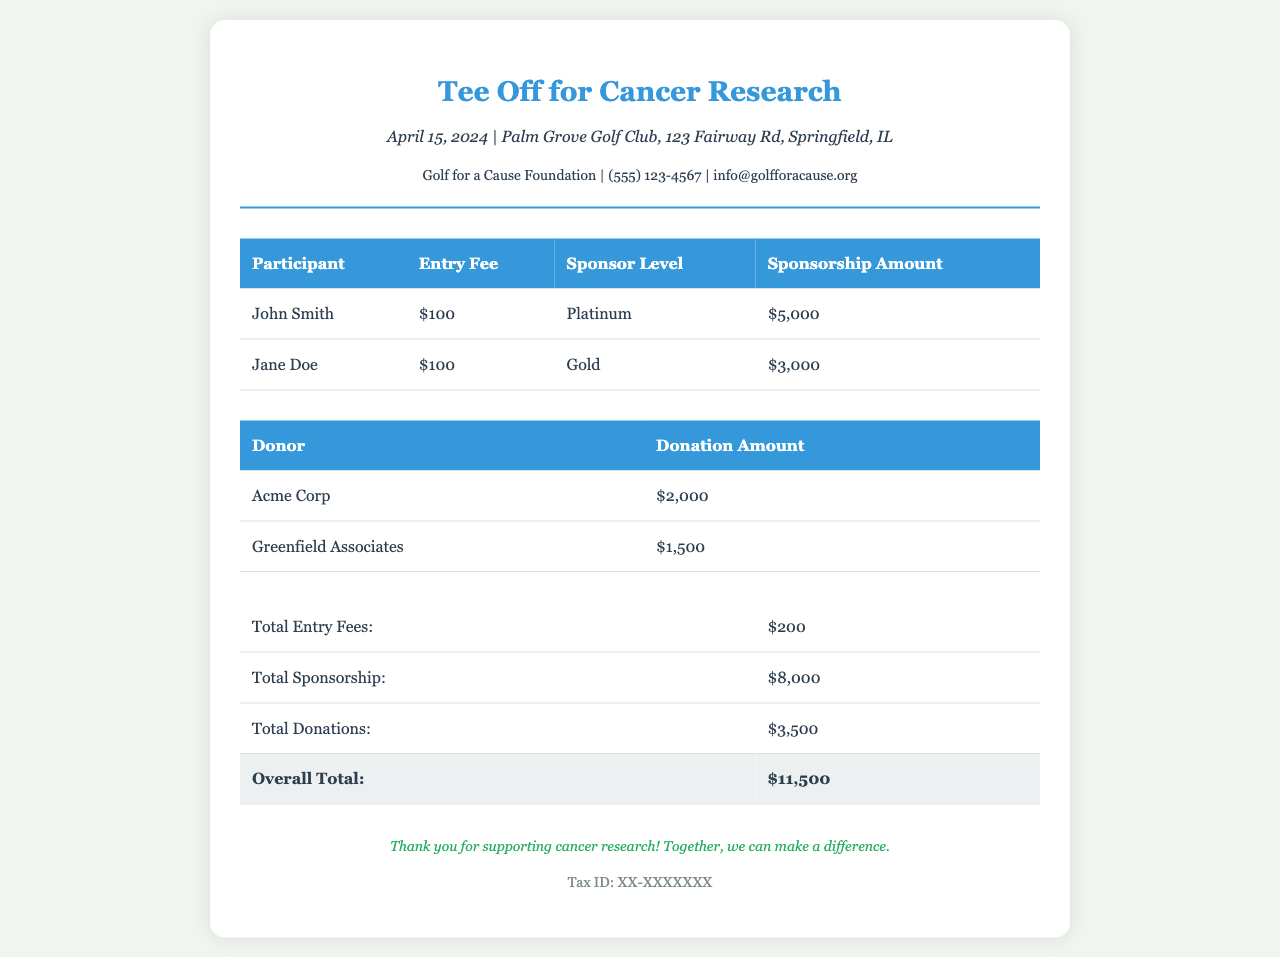What is the name of the event? The event name is mentioned at the top of the document.
Answer: Tee Off for Cancer Research What is the date of the event? The date of the event is listed in the event details section.
Answer: April 15, 2024 How much is the entry fee for each participant? The entry fee is listed in the table under the "Entry Fee" column.
Answer: $100 Who is a Platinum sponsor? The sponsorship details can be found in the sponsorship table.
Answer: John Smith What is the total amount raised from sponsorships? The total sponsorship amount is at the bottom of the sponsorship table.
Answer: $8,000 What is the total donation amount? The total donation amount is stated at the bottom of the donations table.
Answer: $3,500 What is the overall total raised for the event? The overall total is found at the bottom of the event totals table.
Answer: $11,500 How many participants are listed? The number of participants can be counted from the participants' table.
Answer: 2 What was the donation amount from Greenfield Associates? The donation amount is provided in the donations table.
Answer: $1,500 